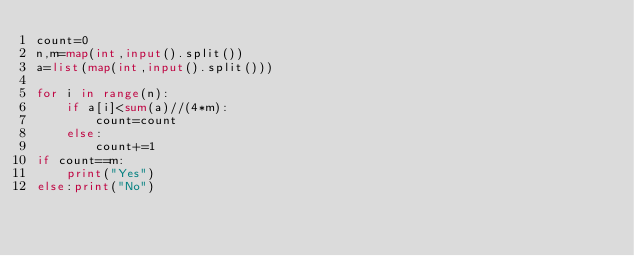Convert code to text. <code><loc_0><loc_0><loc_500><loc_500><_Python_>count=0
n,m=map(int,input().split())
a=list(map(int,input().split()))

for i in range(n):
    if a[i]<sum(a)//(4*m):
        count=count
    else:
        count+=1
if count==m:
    print("Yes")
else:print("No")
        </code> 